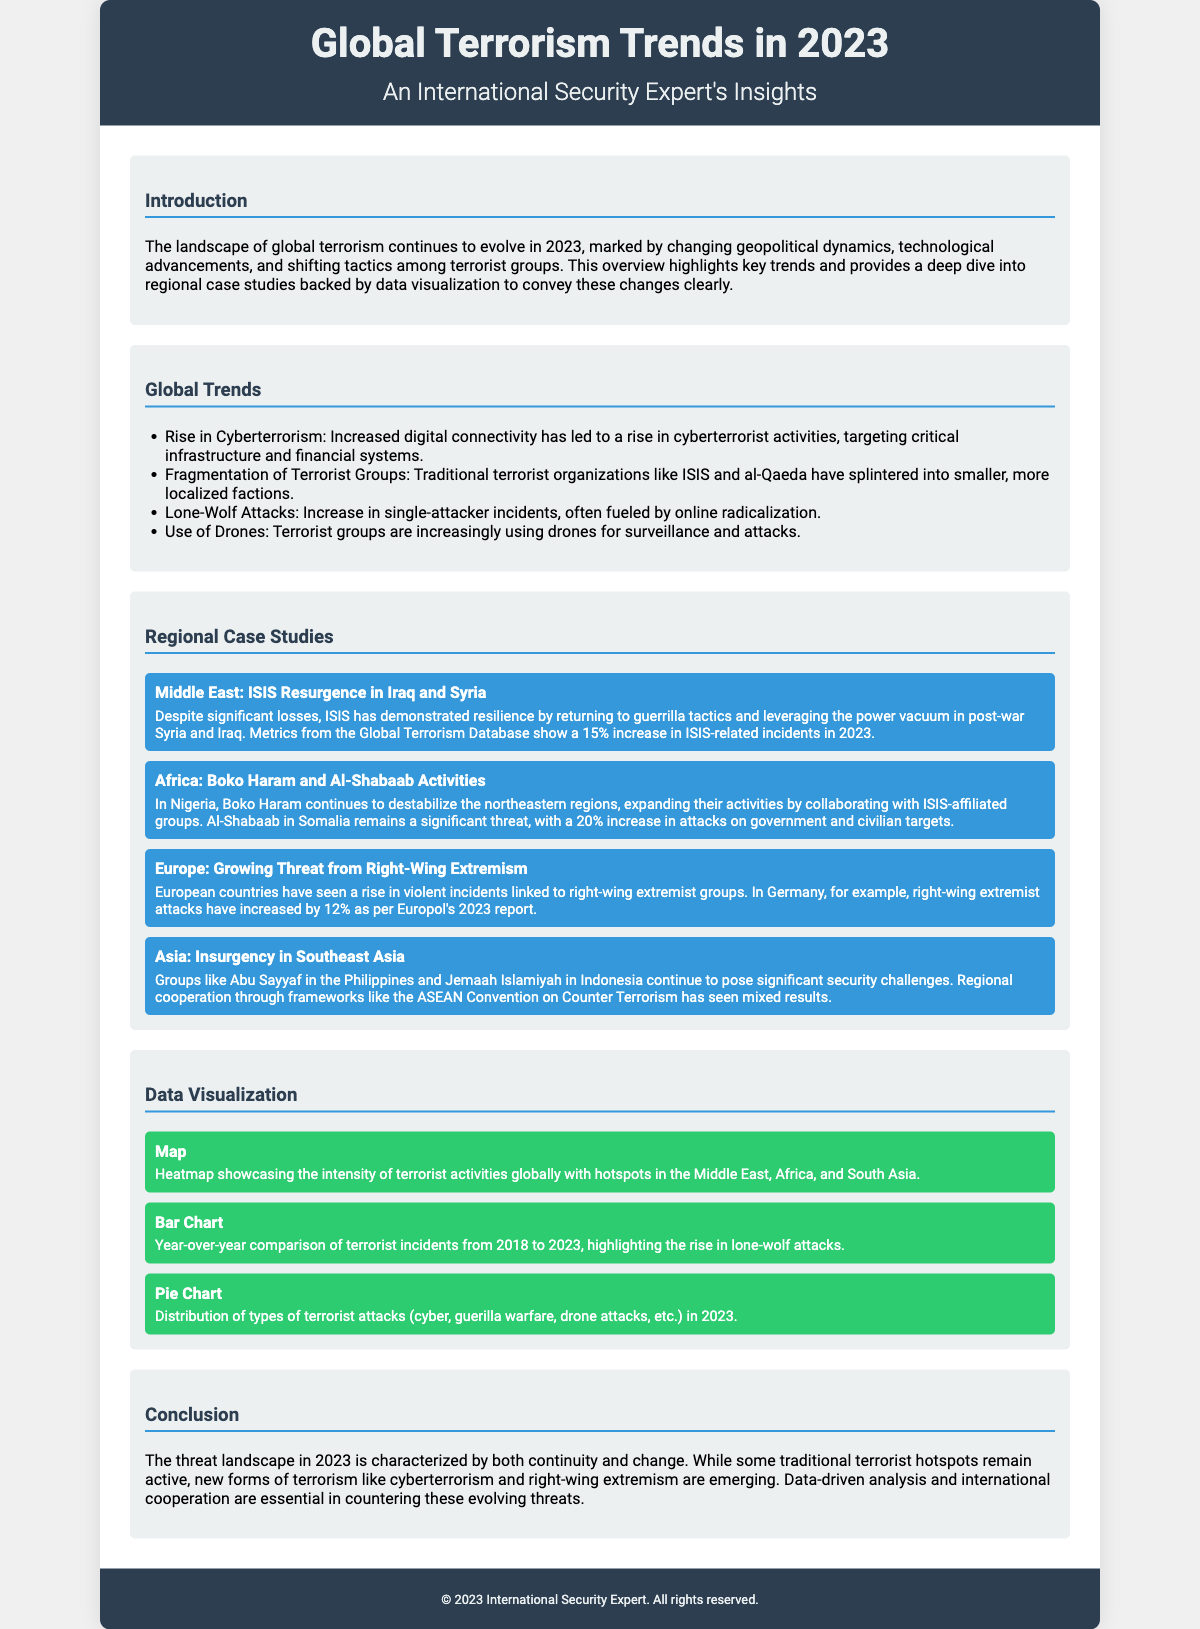what year did the overview focus on? The document is an overview for the year 2023.
Answer: 2023 what was the percentage increase in ISIS-related incidents in 2023? The document states that there was a 15% increase in ISIS-related incidents in 2023.
Answer: 15% which extremist activities faced a 12% increase in Germany? The document mentions that right-wing extremist attacks in Germany increased by 12%.
Answer: right-wing extremist attacks how has the use of drones evolved among terrorist groups? The overview indicates that terrorist groups are increasingly using drones for surveillance and attacks.
Answer: increased use what is one key factor contributing to the rise in cyberterrorism? The document states that increased digital connectivity has led to a rise in cyberterrorism activities.
Answer: increased digital connectivity which two groups collaborated to destabilize northeastern Nigeria? The overview notes that Boko Haram collaborates with ISIS-affiliated groups in Nigeria.
Answer: Boko Haram and ISIS-affiliated groups what type of chart is used to show terrorist incidents from 2018 to 2023? The document describes a bar chart used for year-over-year comparison of terrorist incidents.
Answer: bar chart which region is identified as having a heatmap hotspot for terrorist activities? The document identifies the Middle East, Africa, and South Asia as hotspots on the heatmap.
Answer: Middle East, Africa, and South Asia what does the pie chart illustrate in the document? The pie chart illustrates the distribution of types of terrorist attacks in 2023.
Answer: distribution of types of terrorist attacks 